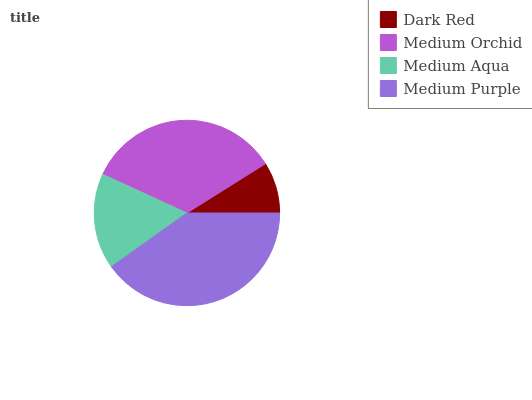Is Dark Red the minimum?
Answer yes or no. Yes. Is Medium Purple the maximum?
Answer yes or no. Yes. Is Medium Orchid the minimum?
Answer yes or no. No. Is Medium Orchid the maximum?
Answer yes or no. No. Is Medium Orchid greater than Dark Red?
Answer yes or no. Yes. Is Dark Red less than Medium Orchid?
Answer yes or no. Yes. Is Dark Red greater than Medium Orchid?
Answer yes or no. No. Is Medium Orchid less than Dark Red?
Answer yes or no. No. Is Medium Orchid the high median?
Answer yes or no. Yes. Is Medium Aqua the low median?
Answer yes or no. Yes. Is Dark Red the high median?
Answer yes or no. No. Is Medium Orchid the low median?
Answer yes or no. No. 